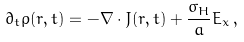Convert formula to latex. <formula><loc_0><loc_0><loc_500><loc_500>\partial _ { t } \rho ( { r } , t ) = - { \nabla } \cdot { J } ( { r } , t ) + \frac { \sigma _ { H } } { a } E _ { x } \, ,</formula> 